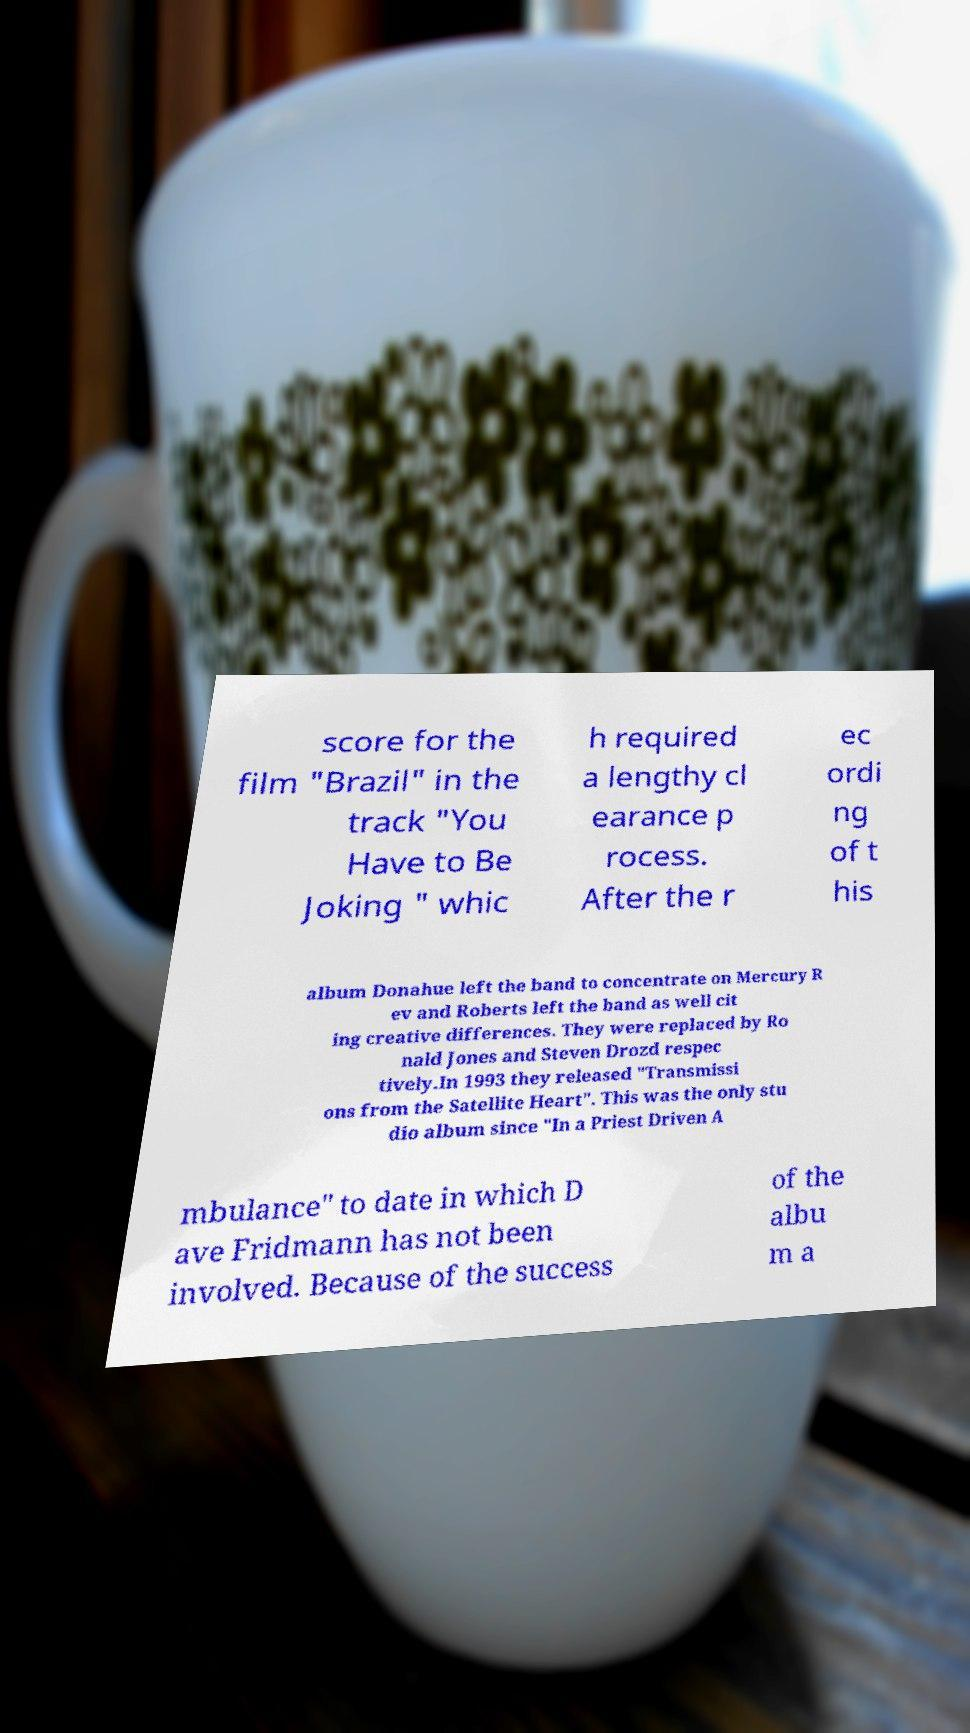I need the written content from this picture converted into text. Can you do that? score for the film "Brazil" in the track "You Have to Be Joking " whic h required a lengthy cl earance p rocess. After the r ec ordi ng of t his album Donahue left the band to concentrate on Mercury R ev and Roberts left the band as well cit ing creative differences. They were replaced by Ro nald Jones and Steven Drozd respec tively.In 1993 they released "Transmissi ons from the Satellite Heart". This was the only stu dio album since "In a Priest Driven A mbulance" to date in which D ave Fridmann has not been involved. Because of the success of the albu m a 